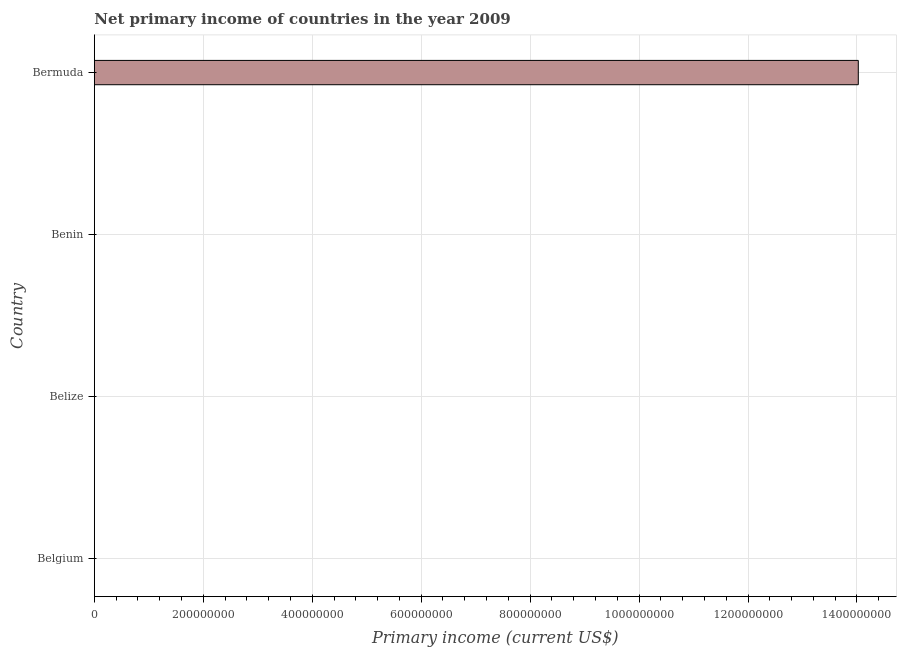Does the graph contain any zero values?
Provide a succinct answer. Yes. Does the graph contain grids?
Your answer should be very brief. Yes. What is the title of the graph?
Offer a terse response. Net primary income of countries in the year 2009. What is the label or title of the X-axis?
Offer a very short reply. Primary income (current US$). What is the amount of primary income in Bermuda?
Make the answer very short. 1.40e+09. Across all countries, what is the maximum amount of primary income?
Offer a terse response. 1.40e+09. In which country was the amount of primary income maximum?
Give a very brief answer. Bermuda. What is the sum of the amount of primary income?
Provide a succinct answer. 1.40e+09. What is the average amount of primary income per country?
Offer a very short reply. 3.51e+08. What is the median amount of primary income?
Ensure brevity in your answer.  0. In how many countries, is the amount of primary income greater than 440000000 US$?
Offer a very short reply. 1. What is the difference between the highest and the lowest amount of primary income?
Your answer should be compact. 1.40e+09. How many countries are there in the graph?
Give a very brief answer. 4. What is the difference between two consecutive major ticks on the X-axis?
Ensure brevity in your answer.  2.00e+08. What is the Primary income (current US$) in Belize?
Offer a very short reply. 0. What is the Primary income (current US$) in Bermuda?
Make the answer very short. 1.40e+09. 